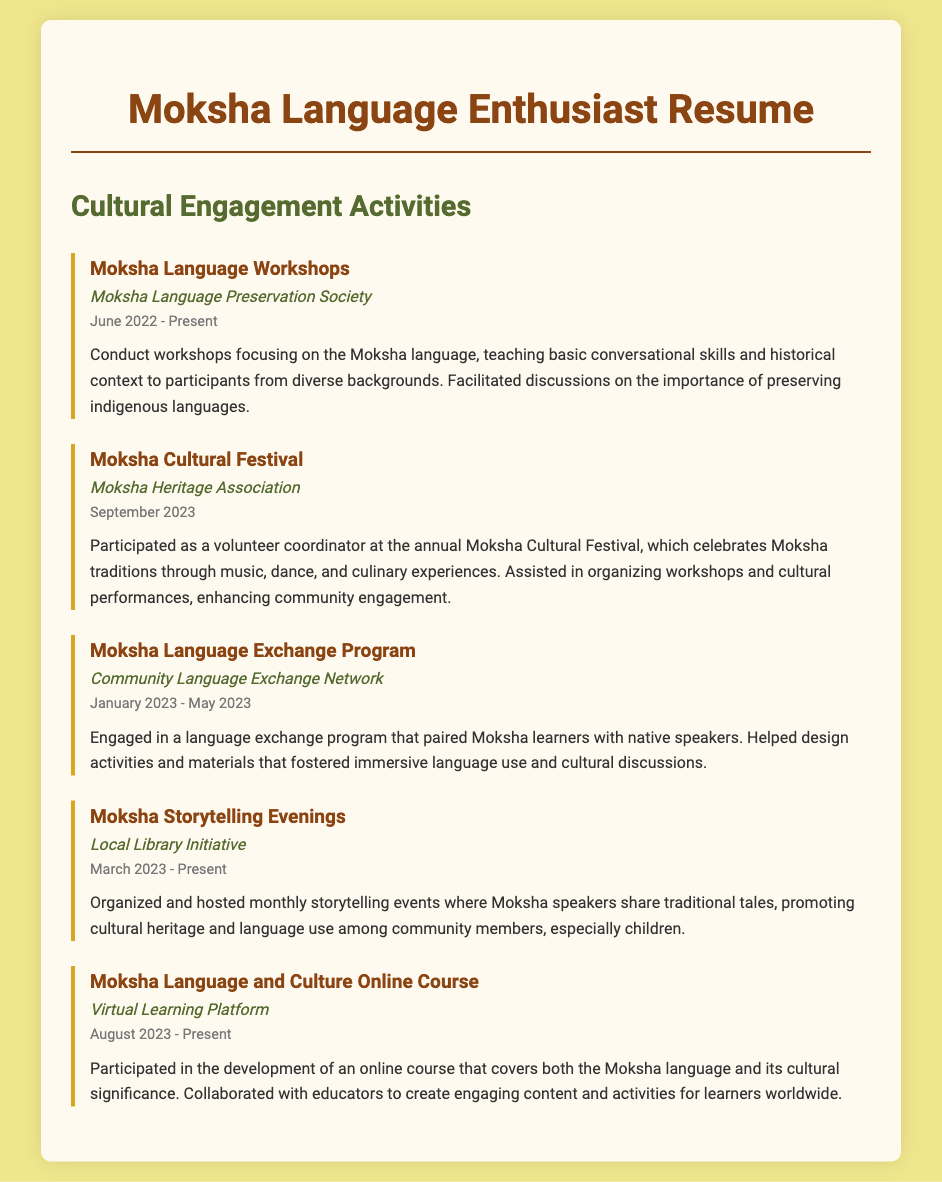What is the title of the first activity? The title of the first activity listed in the document is "Moksha Language Workshops."
Answer: Moksha Language Workshops Who organized the Moksha Cultural Festival? The organization responsible for the Moksha Cultural Festival is the Moksha Heritage Association.
Answer: Moksha Heritage Association When did the Moksha Language Exchange Program take place? The Moksha Language Exchange Program occurred from January 2023 to May 2023.
Answer: January 2023 - May 2023 What is the main focus of the Moksha Storytelling Evenings? The main focus of the Moksha Storytelling Evenings is to share traditional tales and promote cultural heritage.
Answer: Share traditional tales How many cultural engagement activities are listed in the document? There are five cultural engagement activities listed in the document.
Answer: Five What type of events did the Moksha Cultural Festival include? The Moksha Cultural Festival included music, dance, and culinary experiences.
Answer: Music, dance, and culinary experiences Which organization did the participant collaborate with for the online course? The participant collaborated with a Virtual Learning Platform for the Moksha Language and Culture Online Course.
Answer: Virtual Learning Platform Name one primary goal of the Moksha Language Workshops. One primary goal of the Moksha Language Workshops is to teach basic conversational skills.
Answer: Teach basic conversational skills 